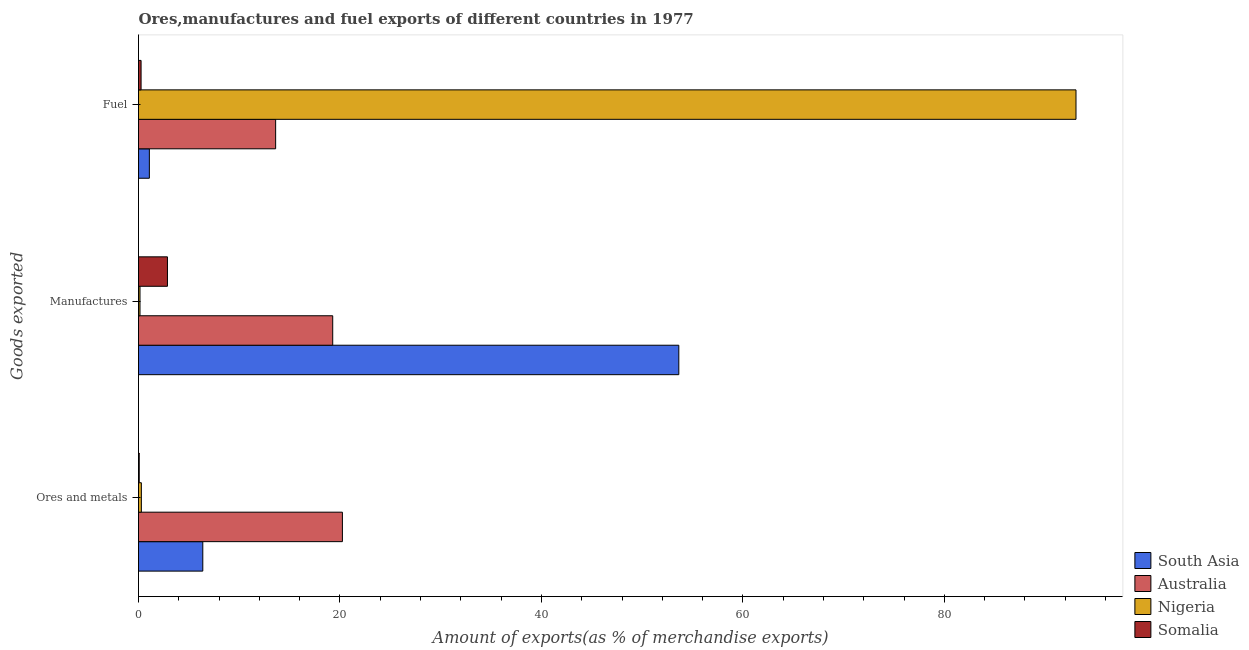How many different coloured bars are there?
Keep it short and to the point. 4. How many groups of bars are there?
Provide a succinct answer. 3. Are the number of bars per tick equal to the number of legend labels?
Your answer should be very brief. Yes. What is the label of the 3rd group of bars from the top?
Give a very brief answer. Ores and metals. What is the percentage of fuel exports in Nigeria?
Offer a very short reply. 93.06. Across all countries, what is the maximum percentage of ores and metals exports?
Your answer should be compact. 20.24. Across all countries, what is the minimum percentage of manufactures exports?
Offer a terse response. 0.15. In which country was the percentage of manufactures exports maximum?
Provide a short and direct response. South Asia. In which country was the percentage of manufactures exports minimum?
Your response must be concise. Nigeria. What is the total percentage of manufactures exports in the graph?
Make the answer very short. 75.93. What is the difference between the percentage of ores and metals exports in Somalia and that in Nigeria?
Ensure brevity in your answer.  -0.21. What is the difference between the percentage of manufactures exports in South Asia and the percentage of ores and metals exports in Nigeria?
Offer a terse response. 53.35. What is the average percentage of ores and metals exports per country?
Provide a short and direct response. 6.74. What is the difference between the percentage of fuel exports and percentage of ores and metals exports in Australia?
Provide a short and direct response. -6.63. In how many countries, is the percentage of fuel exports greater than 76 %?
Your response must be concise. 1. What is the ratio of the percentage of fuel exports in Australia to that in South Asia?
Make the answer very short. 12.63. Is the difference between the percentage of ores and metals exports in Australia and South Asia greater than the difference between the percentage of fuel exports in Australia and South Asia?
Keep it short and to the point. Yes. What is the difference between the highest and the second highest percentage of manufactures exports?
Make the answer very short. 34.36. What is the difference between the highest and the lowest percentage of fuel exports?
Provide a succinct answer. 92.81. In how many countries, is the percentage of manufactures exports greater than the average percentage of manufactures exports taken over all countries?
Offer a terse response. 2. What does the 2nd bar from the top in Fuel represents?
Your answer should be very brief. Nigeria. Is it the case that in every country, the sum of the percentage of ores and metals exports and percentage of manufactures exports is greater than the percentage of fuel exports?
Your answer should be very brief. No. How many countries are there in the graph?
Ensure brevity in your answer.  4. What is the difference between two consecutive major ticks on the X-axis?
Offer a very short reply. 20. Does the graph contain any zero values?
Provide a succinct answer. No. Where does the legend appear in the graph?
Give a very brief answer. Bottom right. How many legend labels are there?
Your answer should be very brief. 4. How are the legend labels stacked?
Give a very brief answer. Vertical. What is the title of the graph?
Offer a terse response. Ores,manufactures and fuel exports of different countries in 1977. What is the label or title of the X-axis?
Your answer should be very brief. Amount of exports(as % of merchandise exports). What is the label or title of the Y-axis?
Ensure brevity in your answer.  Goods exported. What is the Amount of exports(as % of merchandise exports) of South Asia in Ores and metals?
Ensure brevity in your answer.  6.38. What is the Amount of exports(as % of merchandise exports) of Australia in Ores and metals?
Give a very brief answer. 20.24. What is the Amount of exports(as % of merchandise exports) of Nigeria in Ores and metals?
Provide a short and direct response. 0.28. What is the Amount of exports(as % of merchandise exports) of Somalia in Ores and metals?
Ensure brevity in your answer.  0.07. What is the Amount of exports(as % of merchandise exports) of South Asia in Manufactures?
Keep it short and to the point. 53.63. What is the Amount of exports(as % of merchandise exports) in Australia in Manufactures?
Give a very brief answer. 19.28. What is the Amount of exports(as % of merchandise exports) in Nigeria in Manufactures?
Your answer should be compact. 0.15. What is the Amount of exports(as % of merchandise exports) in Somalia in Manufactures?
Your response must be concise. 2.87. What is the Amount of exports(as % of merchandise exports) of South Asia in Fuel?
Offer a very short reply. 1.08. What is the Amount of exports(as % of merchandise exports) in Australia in Fuel?
Give a very brief answer. 13.61. What is the Amount of exports(as % of merchandise exports) of Nigeria in Fuel?
Offer a terse response. 93.06. What is the Amount of exports(as % of merchandise exports) of Somalia in Fuel?
Offer a terse response. 0.26. Across all Goods exported, what is the maximum Amount of exports(as % of merchandise exports) in South Asia?
Ensure brevity in your answer.  53.63. Across all Goods exported, what is the maximum Amount of exports(as % of merchandise exports) in Australia?
Make the answer very short. 20.24. Across all Goods exported, what is the maximum Amount of exports(as % of merchandise exports) of Nigeria?
Your answer should be compact. 93.06. Across all Goods exported, what is the maximum Amount of exports(as % of merchandise exports) of Somalia?
Offer a terse response. 2.87. Across all Goods exported, what is the minimum Amount of exports(as % of merchandise exports) of South Asia?
Offer a very short reply. 1.08. Across all Goods exported, what is the minimum Amount of exports(as % of merchandise exports) of Australia?
Ensure brevity in your answer.  13.61. Across all Goods exported, what is the minimum Amount of exports(as % of merchandise exports) in Nigeria?
Offer a very short reply. 0.15. Across all Goods exported, what is the minimum Amount of exports(as % of merchandise exports) in Somalia?
Your answer should be compact. 0.07. What is the total Amount of exports(as % of merchandise exports) of South Asia in the graph?
Your answer should be compact. 61.09. What is the total Amount of exports(as % of merchandise exports) in Australia in the graph?
Your answer should be compact. 53.13. What is the total Amount of exports(as % of merchandise exports) of Nigeria in the graph?
Keep it short and to the point. 93.49. What is the total Amount of exports(as % of merchandise exports) in Somalia in the graph?
Your answer should be very brief. 3.2. What is the difference between the Amount of exports(as % of merchandise exports) in South Asia in Ores and metals and that in Manufactures?
Your response must be concise. -47.25. What is the difference between the Amount of exports(as % of merchandise exports) of Nigeria in Ores and metals and that in Manufactures?
Offer a terse response. 0.14. What is the difference between the Amount of exports(as % of merchandise exports) of Somalia in Ores and metals and that in Manufactures?
Offer a terse response. -2.8. What is the difference between the Amount of exports(as % of merchandise exports) in South Asia in Ores and metals and that in Fuel?
Your answer should be compact. 5.3. What is the difference between the Amount of exports(as % of merchandise exports) in Australia in Ores and metals and that in Fuel?
Make the answer very short. 6.63. What is the difference between the Amount of exports(as % of merchandise exports) in Nigeria in Ores and metals and that in Fuel?
Your answer should be very brief. -92.78. What is the difference between the Amount of exports(as % of merchandise exports) in Somalia in Ores and metals and that in Fuel?
Provide a short and direct response. -0.18. What is the difference between the Amount of exports(as % of merchandise exports) of South Asia in Manufactures and that in Fuel?
Offer a very short reply. 52.56. What is the difference between the Amount of exports(as % of merchandise exports) in Australia in Manufactures and that in Fuel?
Your response must be concise. 5.67. What is the difference between the Amount of exports(as % of merchandise exports) of Nigeria in Manufactures and that in Fuel?
Make the answer very short. -92.92. What is the difference between the Amount of exports(as % of merchandise exports) of Somalia in Manufactures and that in Fuel?
Ensure brevity in your answer.  2.62. What is the difference between the Amount of exports(as % of merchandise exports) of South Asia in Ores and metals and the Amount of exports(as % of merchandise exports) of Australia in Manufactures?
Keep it short and to the point. -12.9. What is the difference between the Amount of exports(as % of merchandise exports) in South Asia in Ores and metals and the Amount of exports(as % of merchandise exports) in Nigeria in Manufactures?
Provide a short and direct response. 6.23. What is the difference between the Amount of exports(as % of merchandise exports) in South Asia in Ores and metals and the Amount of exports(as % of merchandise exports) in Somalia in Manufactures?
Ensure brevity in your answer.  3.51. What is the difference between the Amount of exports(as % of merchandise exports) of Australia in Ores and metals and the Amount of exports(as % of merchandise exports) of Nigeria in Manufactures?
Your answer should be compact. 20.09. What is the difference between the Amount of exports(as % of merchandise exports) of Australia in Ores and metals and the Amount of exports(as % of merchandise exports) of Somalia in Manufactures?
Provide a succinct answer. 17.37. What is the difference between the Amount of exports(as % of merchandise exports) of Nigeria in Ores and metals and the Amount of exports(as % of merchandise exports) of Somalia in Manufactures?
Keep it short and to the point. -2.59. What is the difference between the Amount of exports(as % of merchandise exports) in South Asia in Ores and metals and the Amount of exports(as % of merchandise exports) in Australia in Fuel?
Your answer should be very brief. -7.23. What is the difference between the Amount of exports(as % of merchandise exports) in South Asia in Ores and metals and the Amount of exports(as % of merchandise exports) in Nigeria in Fuel?
Your answer should be very brief. -86.68. What is the difference between the Amount of exports(as % of merchandise exports) of South Asia in Ores and metals and the Amount of exports(as % of merchandise exports) of Somalia in Fuel?
Offer a very short reply. 6.13. What is the difference between the Amount of exports(as % of merchandise exports) in Australia in Ores and metals and the Amount of exports(as % of merchandise exports) in Nigeria in Fuel?
Your answer should be very brief. -72.82. What is the difference between the Amount of exports(as % of merchandise exports) in Australia in Ores and metals and the Amount of exports(as % of merchandise exports) in Somalia in Fuel?
Keep it short and to the point. 19.99. What is the difference between the Amount of exports(as % of merchandise exports) of Nigeria in Ores and metals and the Amount of exports(as % of merchandise exports) of Somalia in Fuel?
Your answer should be compact. 0.03. What is the difference between the Amount of exports(as % of merchandise exports) of South Asia in Manufactures and the Amount of exports(as % of merchandise exports) of Australia in Fuel?
Provide a short and direct response. 40.02. What is the difference between the Amount of exports(as % of merchandise exports) in South Asia in Manufactures and the Amount of exports(as % of merchandise exports) in Nigeria in Fuel?
Offer a very short reply. -39.43. What is the difference between the Amount of exports(as % of merchandise exports) in South Asia in Manufactures and the Amount of exports(as % of merchandise exports) in Somalia in Fuel?
Make the answer very short. 53.38. What is the difference between the Amount of exports(as % of merchandise exports) in Australia in Manufactures and the Amount of exports(as % of merchandise exports) in Nigeria in Fuel?
Your answer should be compact. -73.78. What is the difference between the Amount of exports(as % of merchandise exports) in Australia in Manufactures and the Amount of exports(as % of merchandise exports) in Somalia in Fuel?
Your response must be concise. 19.02. What is the difference between the Amount of exports(as % of merchandise exports) in Nigeria in Manufactures and the Amount of exports(as % of merchandise exports) in Somalia in Fuel?
Your answer should be very brief. -0.11. What is the average Amount of exports(as % of merchandise exports) in South Asia per Goods exported?
Make the answer very short. 20.36. What is the average Amount of exports(as % of merchandise exports) in Australia per Goods exported?
Offer a terse response. 17.71. What is the average Amount of exports(as % of merchandise exports) of Nigeria per Goods exported?
Provide a succinct answer. 31.16. What is the average Amount of exports(as % of merchandise exports) in Somalia per Goods exported?
Your answer should be very brief. 1.07. What is the difference between the Amount of exports(as % of merchandise exports) in South Asia and Amount of exports(as % of merchandise exports) in Australia in Ores and metals?
Provide a short and direct response. -13.86. What is the difference between the Amount of exports(as % of merchandise exports) in South Asia and Amount of exports(as % of merchandise exports) in Nigeria in Ores and metals?
Give a very brief answer. 6.1. What is the difference between the Amount of exports(as % of merchandise exports) in South Asia and Amount of exports(as % of merchandise exports) in Somalia in Ores and metals?
Your response must be concise. 6.31. What is the difference between the Amount of exports(as % of merchandise exports) of Australia and Amount of exports(as % of merchandise exports) of Nigeria in Ores and metals?
Provide a succinct answer. 19.96. What is the difference between the Amount of exports(as % of merchandise exports) in Australia and Amount of exports(as % of merchandise exports) in Somalia in Ores and metals?
Your answer should be compact. 20.17. What is the difference between the Amount of exports(as % of merchandise exports) of Nigeria and Amount of exports(as % of merchandise exports) of Somalia in Ores and metals?
Ensure brevity in your answer.  0.21. What is the difference between the Amount of exports(as % of merchandise exports) in South Asia and Amount of exports(as % of merchandise exports) in Australia in Manufactures?
Keep it short and to the point. 34.36. What is the difference between the Amount of exports(as % of merchandise exports) in South Asia and Amount of exports(as % of merchandise exports) in Nigeria in Manufactures?
Ensure brevity in your answer.  53.49. What is the difference between the Amount of exports(as % of merchandise exports) of South Asia and Amount of exports(as % of merchandise exports) of Somalia in Manufactures?
Keep it short and to the point. 50.76. What is the difference between the Amount of exports(as % of merchandise exports) in Australia and Amount of exports(as % of merchandise exports) in Nigeria in Manufactures?
Provide a succinct answer. 19.13. What is the difference between the Amount of exports(as % of merchandise exports) of Australia and Amount of exports(as % of merchandise exports) of Somalia in Manufactures?
Keep it short and to the point. 16.41. What is the difference between the Amount of exports(as % of merchandise exports) in Nigeria and Amount of exports(as % of merchandise exports) in Somalia in Manufactures?
Offer a very short reply. -2.72. What is the difference between the Amount of exports(as % of merchandise exports) of South Asia and Amount of exports(as % of merchandise exports) of Australia in Fuel?
Ensure brevity in your answer.  -12.54. What is the difference between the Amount of exports(as % of merchandise exports) in South Asia and Amount of exports(as % of merchandise exports) in Nigeria in Fuel?
Ensure brevity in your answer.  -91.99. What is the difference between the Amount of exports(as % of merchandise exports) of South Asia and Amount of exports(as % of merchandise exports) of Somalia in Fuel?
Offer a very short reply. 0.82. What is the difference between the Amount of exports(as % of merchandise exports) of Australia and Amount of exports(as % of merchandise exports) of Nigeria in Fuel?
Make the answer very short. -79.45. What is the difference between the Amount of exports(as % of merchandise exports) in Australia and Amount of exports(as % of merchandise exports) in Somalia in Fuel?
Make the answer very short. 13.36. What is the difference between the Amount of exports(as % of merchandise exports) in Nigeria and Amount of exports(as % of merchandise exports) in Somalia in Fuel?
Your answer should be very brief. 92.81. What is the ratio of the Amount of exports(as % of merchandise exports) in South Asia in Ores and metals to that in Manufactures?
Provide a short and direct response. 0.12. What is the ratio of the Amount of exports(as % of merchandise exports) in Australia in Ores and metals to that in Manufactures?
Offer a very short reply. 1.05. What is the ratio of the Amount of exports(as % of merchandise exports) in Nigeria in Ores and metals to that in Manufactures?
Keep it short and to the point. 1.91. What is the ratio of the Amount of exports(as % of merchandise exports) in Somalia in Ores and metals to that in Manufactures?
Offer a terse response. 0.03. What is the ratio of the Amount of exports(as % of merchandise exports) in South Asia in Ores and metals to that in Fuel?
Provide a succinct answer. 5.92. What is the ratio of the Amount of exports(as % of merchandise exports) in Australia in Ores and metals to that in Fuel?
Your answer should be very brief. 1.49. What is the ratio of the Amount of exports(as % of merchandise exports) in Nigeria in Ores and metals to that in Fuel?
Offer a very short reply. 0. What is the ratio of the Amount of exports(as % of merchandise exports) in Somalia in Ores and metals to that in Fuel?
Keep it short and to the point. 0.28. What is the ratio of the Amount of exports(as % of merchandise exports) in South Asia in Manufactures to that in Fuel?
Your response must be concise. 49.77. What is the ratio of the Amount of exports(as % of merchandise exports) of Australia in Manufactures to that in Fuel?
Ensure brevity in your answer.  1.42. What is the ratio of the Amount of exports(as % of merchandise exports) of Nigeria in Manufactures to that in Fuel?
Your answer should be very brief. 0. What is the ratio of the Amount of exports(as % of merchandise exports) in Somalia in Manufactures to that in Fuel?
Your response must be concise. 11.26. What is the difference between the highest and the second highest Amount of exports(as % of merchandise exports) in South Asia?
Offer a very short reply. 47.25. What is the difference between the highest and the second highest Amount of exports(as % of merchandise exports) of Nigeria?
Your answer should be very brief. 92.78. What is the difference between the highest and the second highest Amount of exports(as % of merchandise exports) of Somalia?
Provide a succinct answer. 2.62. What is the difference between the highest and the lowest Amount of exports(as % of merchandise exports) of South Asia?
Offer a very short reply. 52.56. What is the difference between the highest and the lowest Amount of exports(as % of merchandise exports) in Australia?
Provide a succinct answer. 6.63. What is the difference between the highest and the lowest Amount of exports(as % of merchandise exports) in Nigeria?
Give a very brief answer. 92.92. What is the difference between the highest and the lowest Amount of exports(as % of merchandise exports) in Somalia?
Provide a short and direct response. 2.8. 